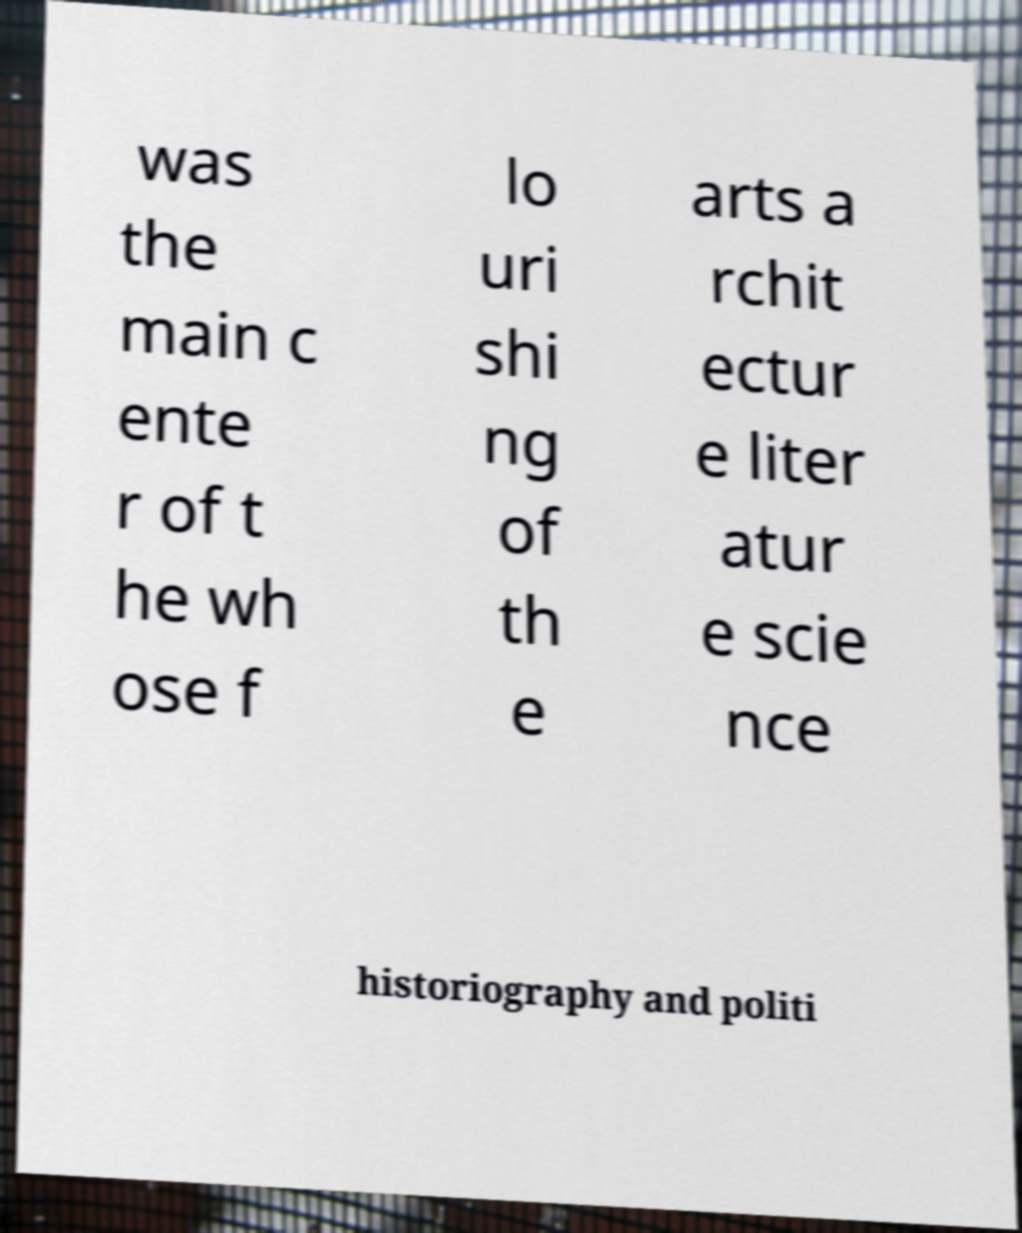For documentation purposes, I need the text within this image transcribed. Could you provide that? was the main c ente r of t he wh ose f lo uri shi ng of th e arts a rchit ectur e liter atur e scie nce historiography and politi 